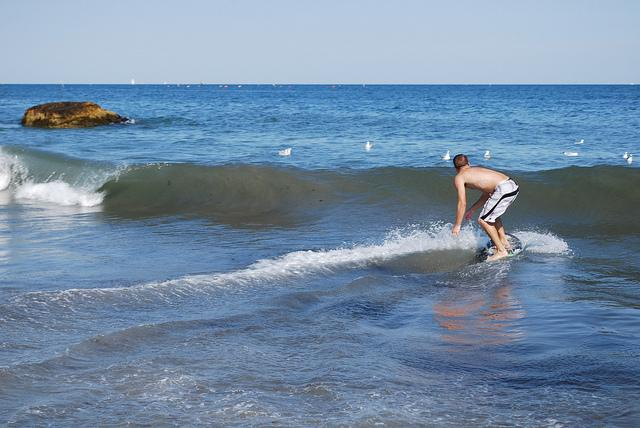Why is he crouching over? Please explain your reasoning. maintain balance. When one is trying to maintain their balance on a board like this they would get in the stance depicted. 